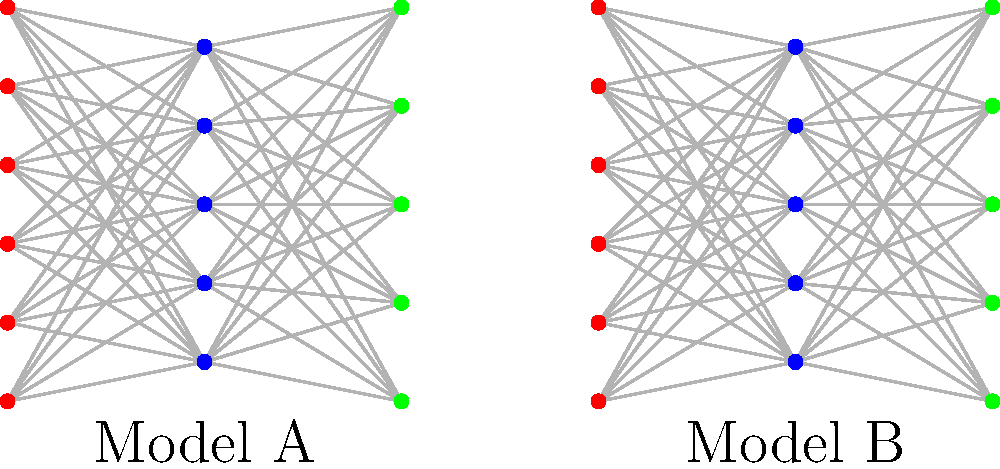Consider the two parallel distributed processing models (Model A and Model B) visualized as layered networks. Both models have three layers with fully connected nodes between adjacent layers. Analyze the congruence of these models in terms of their structural properties and potential functional equivalence. What key factor determines whether these models are computationally congruent, despite their apparent structural similarity? To determine the congruence of the two parallel distributed processing models, we need to consider several factors:

1. Structural similarity:
   - Both models have three layers.
   - The number of nodes in each layer is identical for both models.
   - Both models have full connectivity between adjacent layers.

2. Node activation functions:
   - The activation functions for each node are not specified in the diagram.
   - Different activation functions (e.g., sigmoid, ReLU, tanh) can lead to different computational properties.

3. Weight matrices:
   - The weights of the connections between nodes are not shown in the diagram.
   - Different weight configurations can result in vastly different computational behaviors.

4. Learning algorithms:
   - The learning algorithm used to train each model is not specified.
   - Different learning algorithms (e.g., backpropagation, Hebbian learning) can lead to different weight configurations and, consequently, different computational properties.

5. Input-output mappings:
   - The specific input-output mappings of the models are not provided.
   - Two structurally similar models can have different functional behaviors depending on how they map inputs to outputs.

The key factor determining computational congruence is the combination of weight matrices and activation functions. Even with identical structures, if the weight matrices or activation functions differ, the models may not be computationally congruent.

To establish computational congruence, we would need to prove that:

$$\forall x \in X, f_A(x) = f_B(x)$$

Where $X$ is the input space, and $f_A$ and $f_B$ are the functions computed by Model A and Model B, respectively.

This equality must hold for all possible inputs, which depends on the specific weight configurations and activation functions of each model.
Answer: Weight matrices and activation functions 